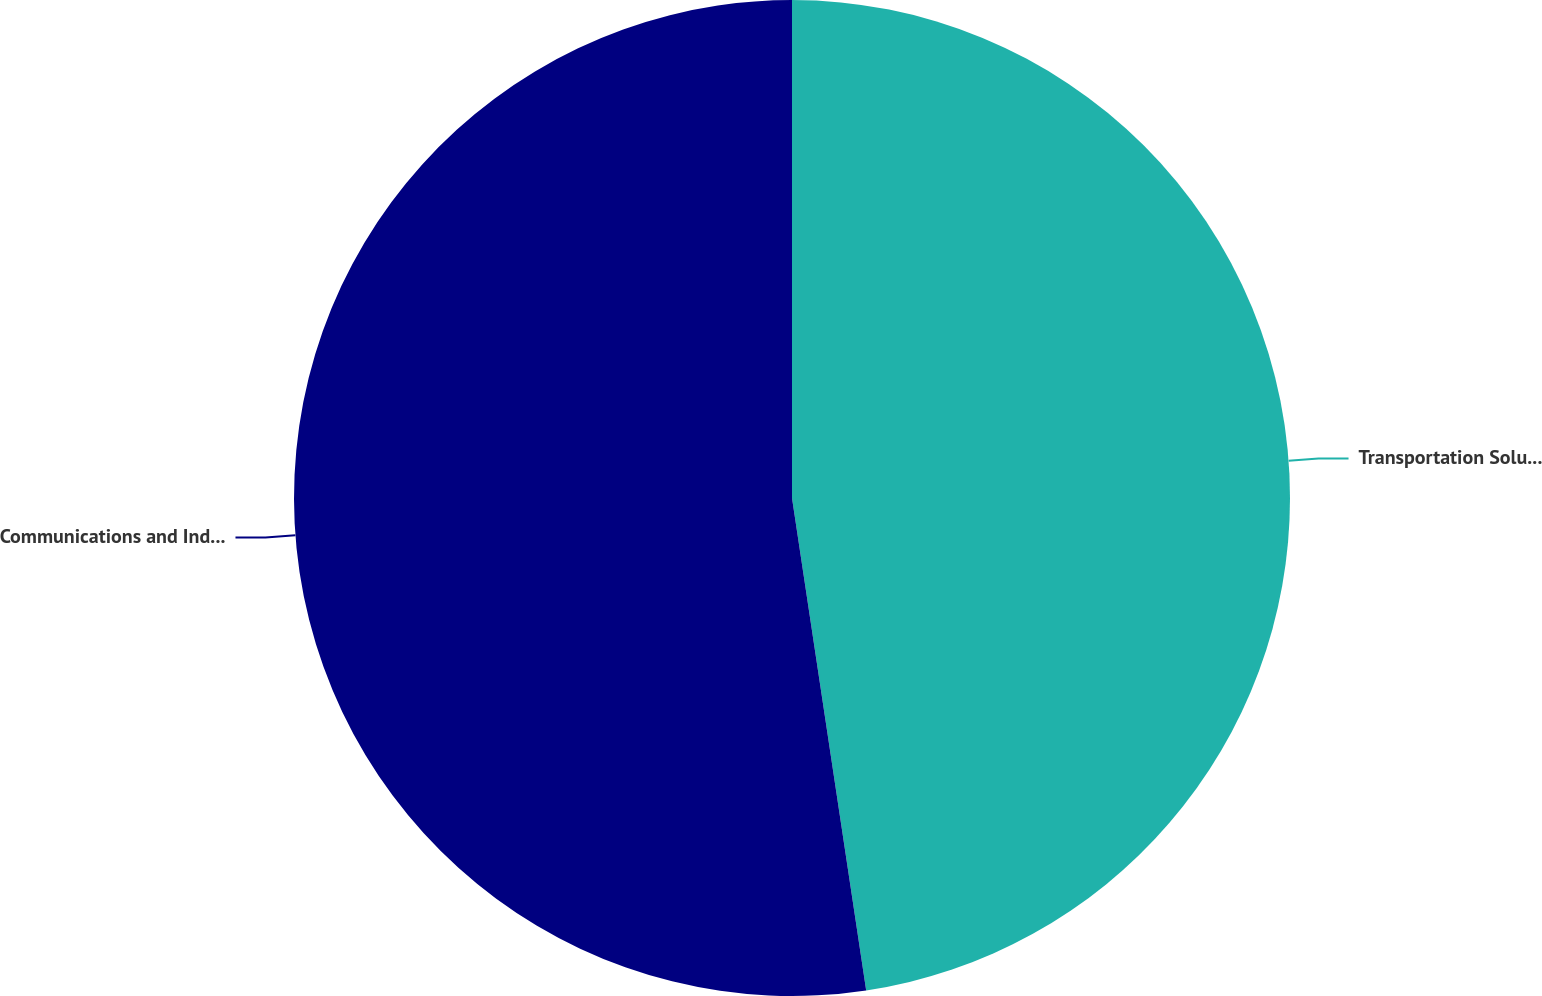Convert chart. <chart><loc_0><loc_0><loc_500><loc_500><pie_chart><fcel>Transportation Solutions<fcel>Communications and Industrial<nl><fcel>47.62%<fcel>52.38%<nl></chart> 